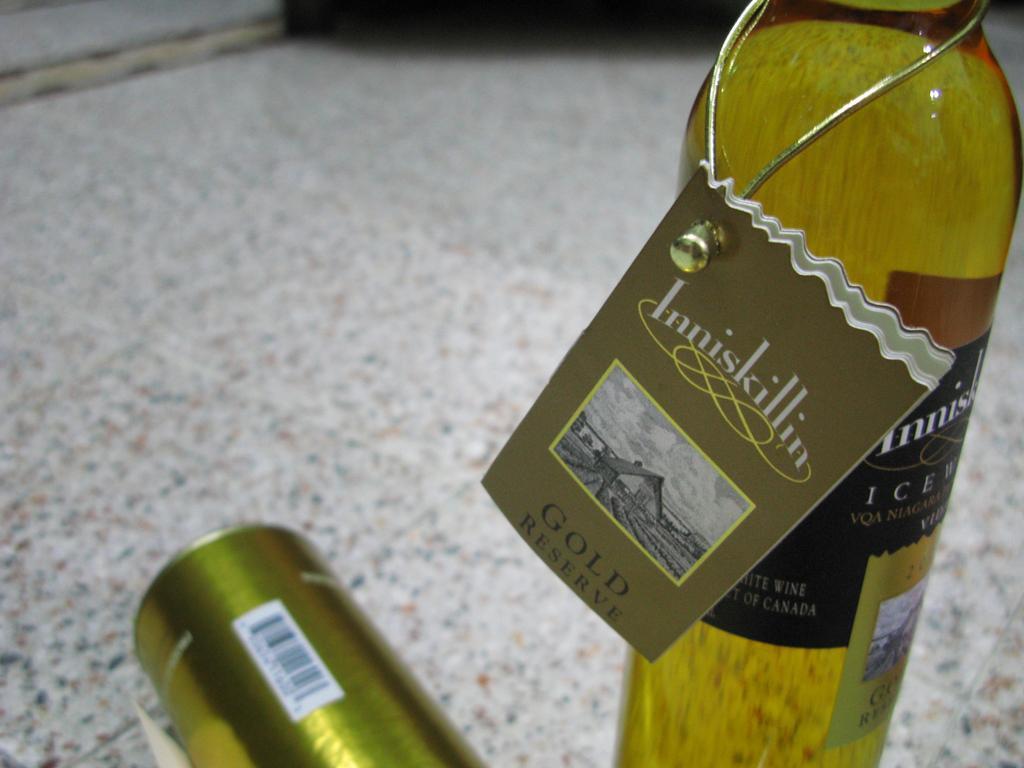How would you summarize this image in a sentence or two? In this image, there is a bottle on the right side of the image. It has label and contains some text. There is a tin in the bottom left of the image. 